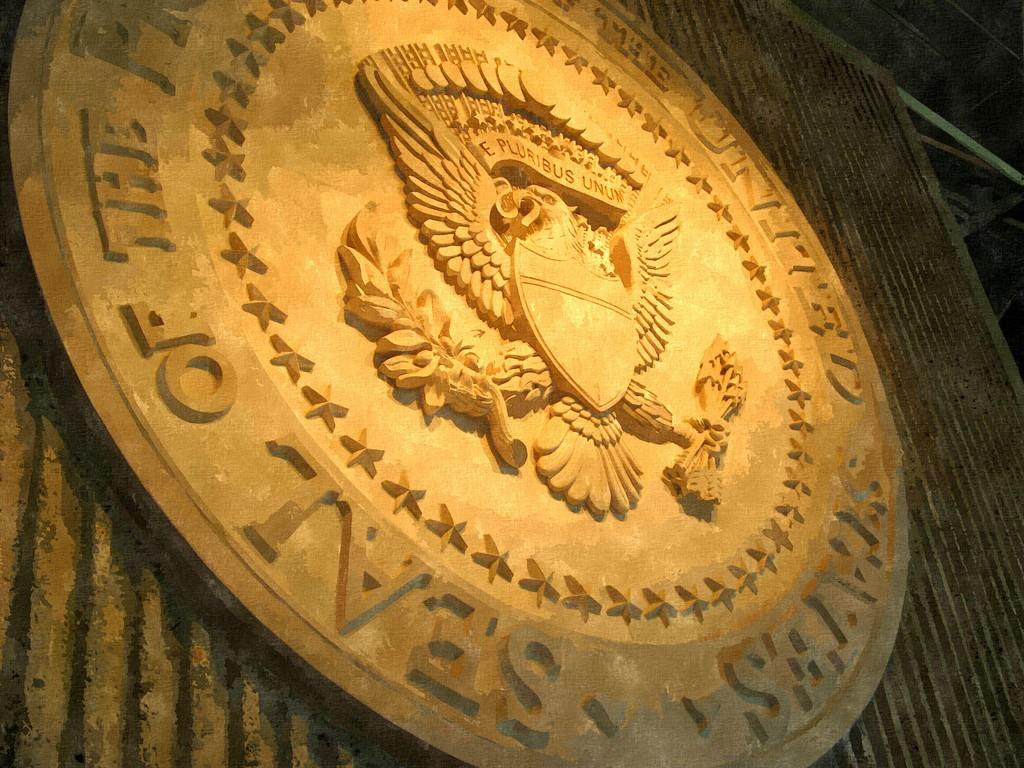<image>
Give a short and clear explanation of the subsequent image. An emblem with an eagle also has the word seal on it. 